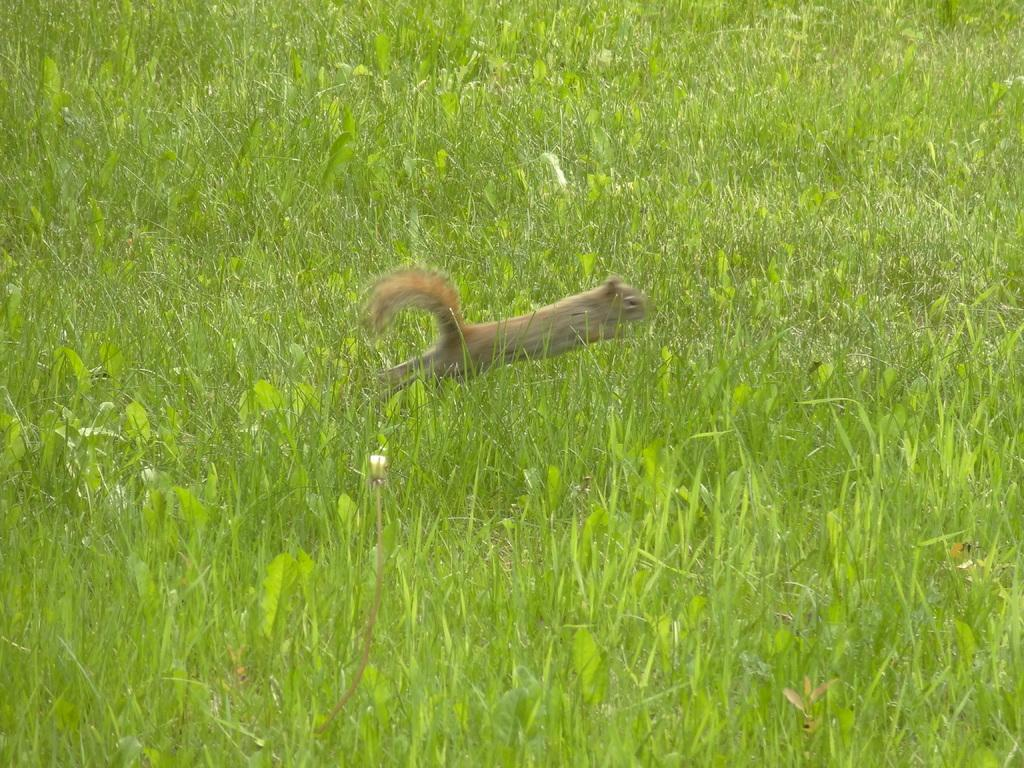What type of vegetation is present in the image? There is green grass in the image. What animal can be seen in the image? There is a cream-colored squirrel in the image. What type of game is the squirrel playing in the image? There is no game present in the image; it simply shows a squirrel on green grass. What tool is the squirrel using to build a nest in the image? There is no tool or nest-building activity depicted in the image; it only shows a squirrel on green grass. 